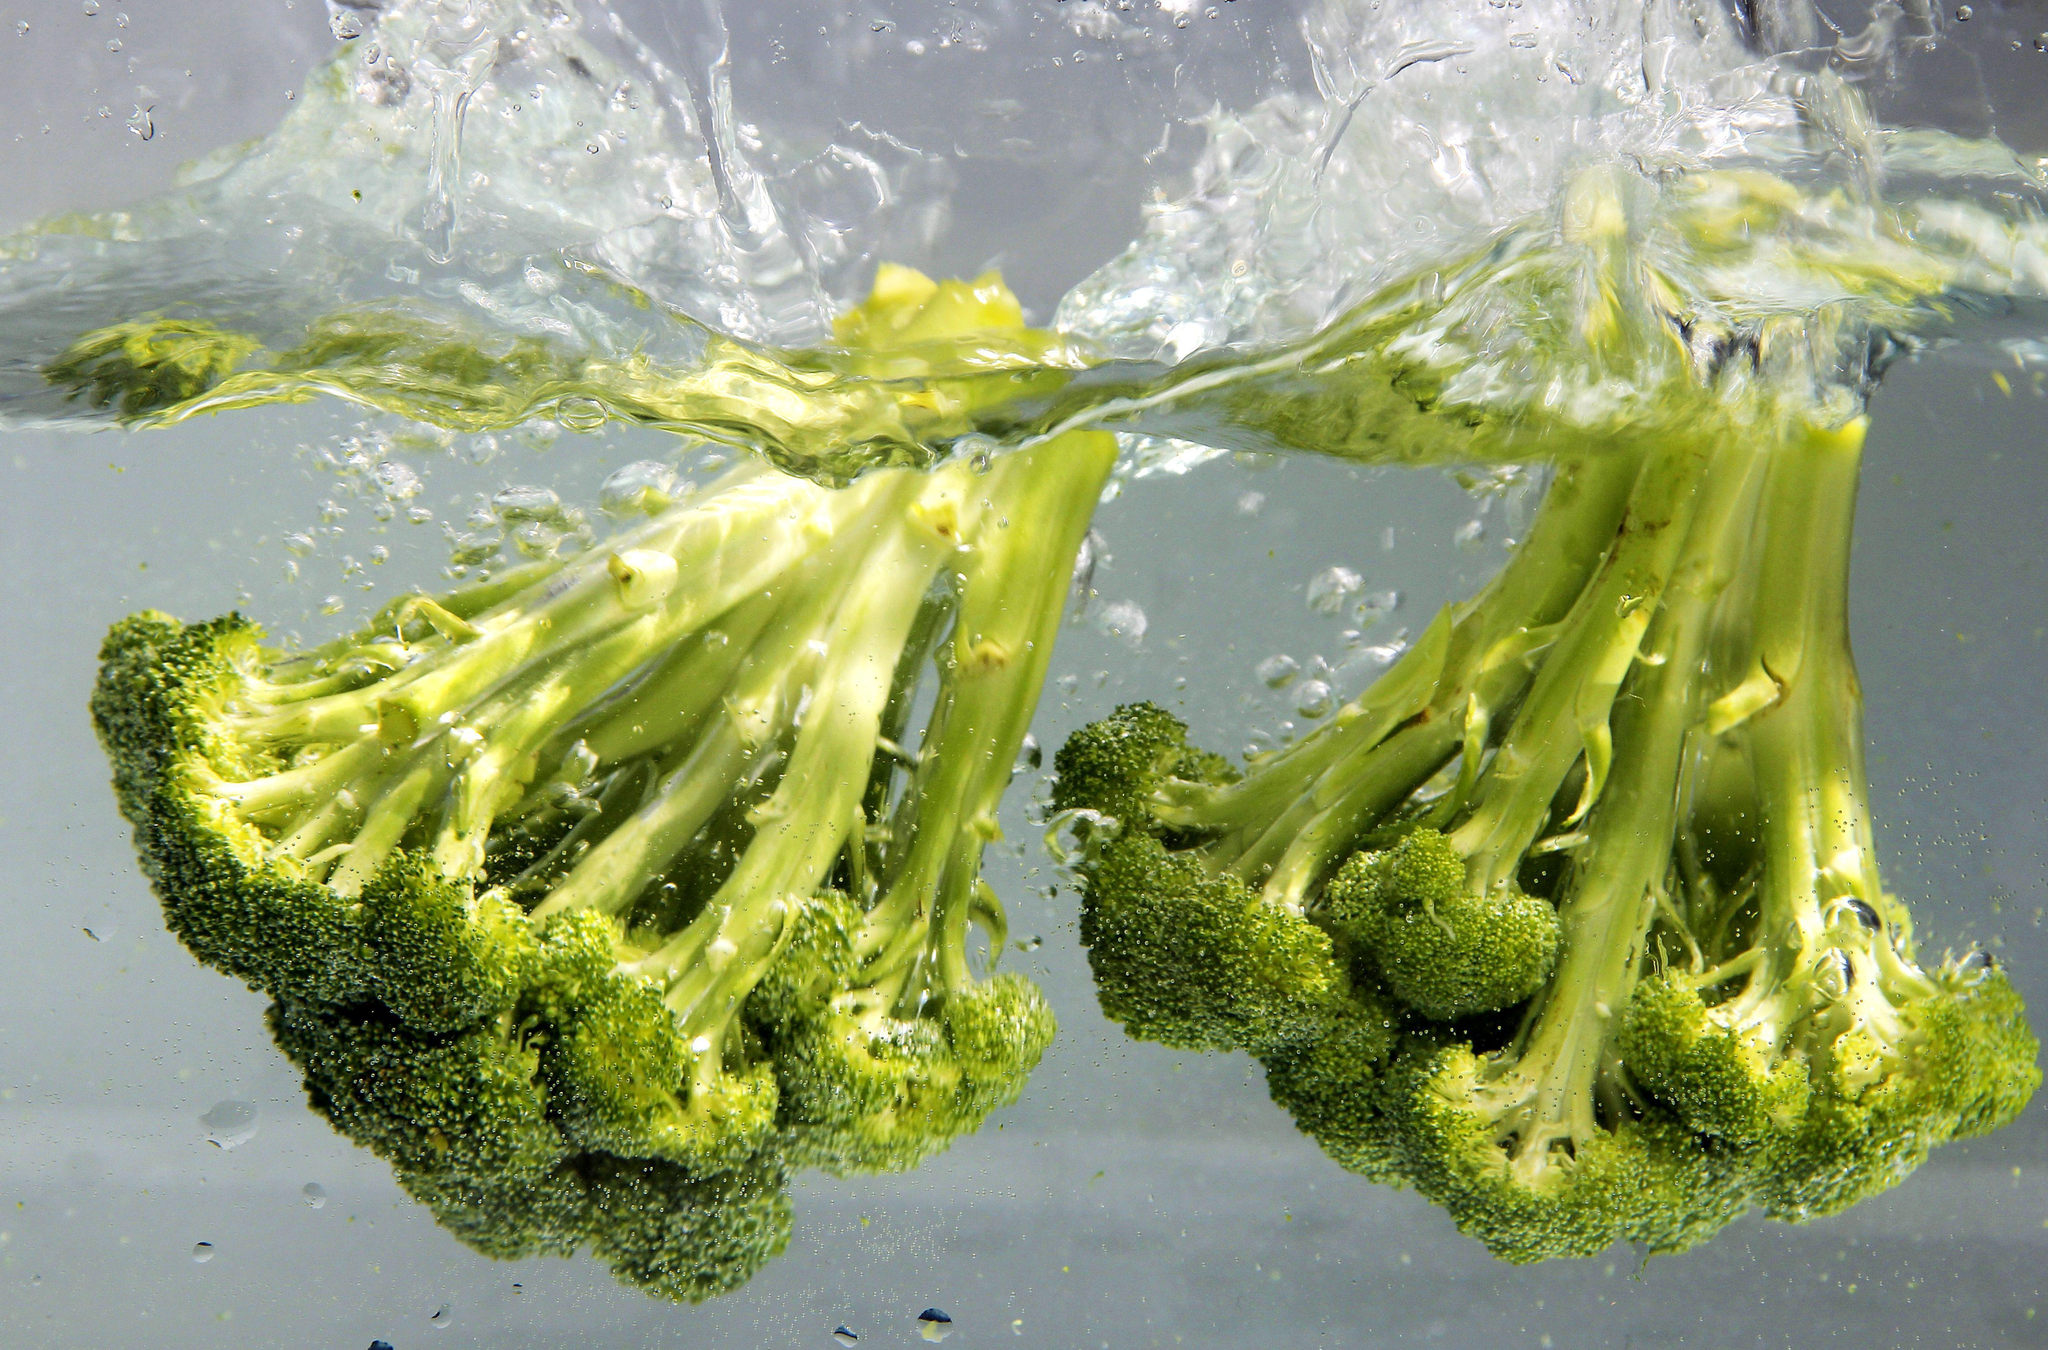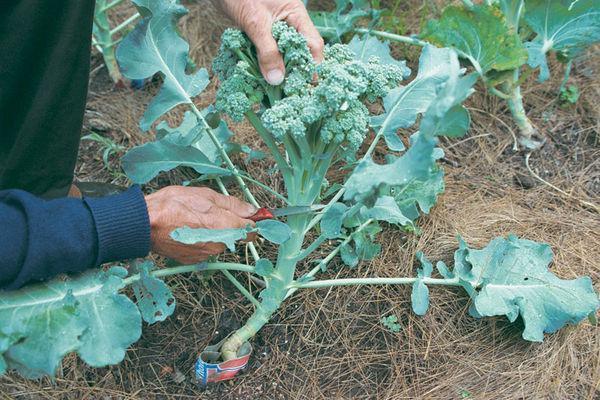The first image is the image on the left, the second image is the image on the right. Considering the images on both sides, is "There is fresh broccoli in a field." valid? Answer yes or no. Yes. The first image is the image on the left, the second image is the image on the right. Considering the images on both sides, is "In at least one image there is a total of one head of broccoli still growing on a stalk." valid? Answer yes or no. Yes. 